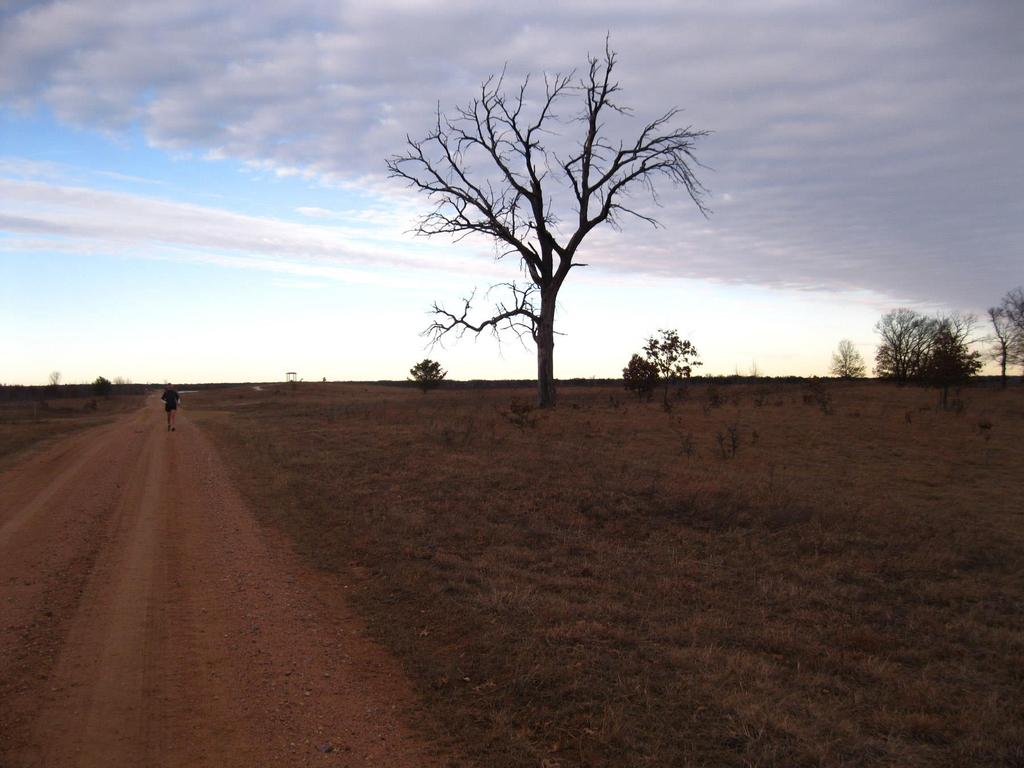What is the main subject of the image? There is a person walking in the image. Where is the person walking? The person is on a path. On which side of the image is the path located? The path is on the left side of the image. What type of landscape surrounds the path? There is grassland on either side of the path. What can be seen in the background of the image? There are trees in the background of the image. What is visible in the sky? The sky is visible in the image, and clouds are present. What type of sugar is being used to sweeten the person's shirt in the image? There is no sugar or shirt mentioned in the image; the person is simply walking on a path. 